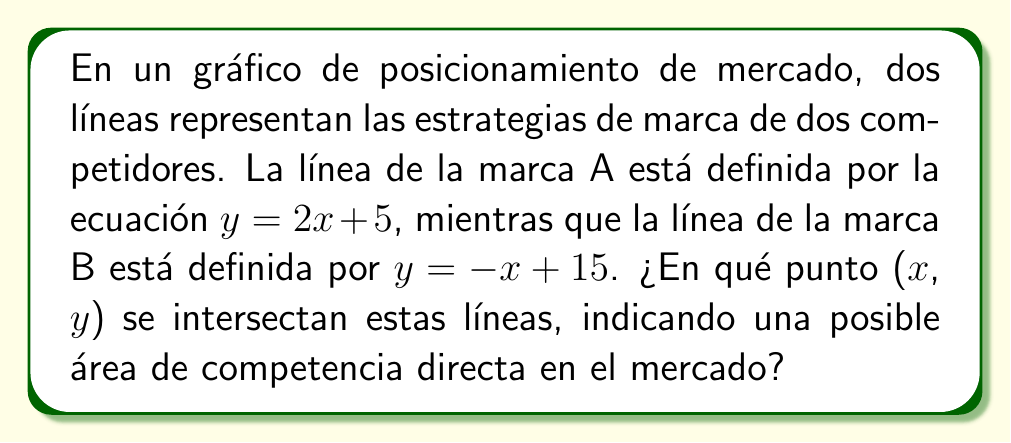Show me your answer to this math problem. Para encontrar el punto de intersección de estas dos líneas, seguiremos estos pasos:

1) Tenemos dos ecuaciones:
   Línea A: $y = 2x + 5$
   Línea B: $y = -x + 15$

2) En el punto de intersección, las coordenadas ($x$, $y$) satisfacen ambas ecuaciones. Por lo tanto, podemos igualarlas:

   $2x + 5 = -x + 15$

3) Resolvemos esta ecuación para $x$:
   $2x + 5 = -x + 15$
   $3x = 10$
   $x = \frac{10}{3}$

4) Ahora que tenemos el valor de $x$, podemos sustituirlo en cualquiera de las ecuaciones originales para encontrar $y$. Usemos la ecuación de la línea A:

   $y = 2(\frac{10}{3}) + 5$
   $y = \frac{20}{3} + 5$
   $y = \frac{20}{3} + \frac{15}{3}$
   $y = \frac{35}{3}$

5) Por lo tanto, el punto de intersección es $(\frac{10}{3}, \frac{35}{3})$.

Este punto representa la posición en el mercado donde ambas marcas compiten directamente, lo que es crucial para desarrollar estrategias de diferenciación y posicionamiento.
Answer: $(\frac{10}{3}, \frac{35}{3})$ 